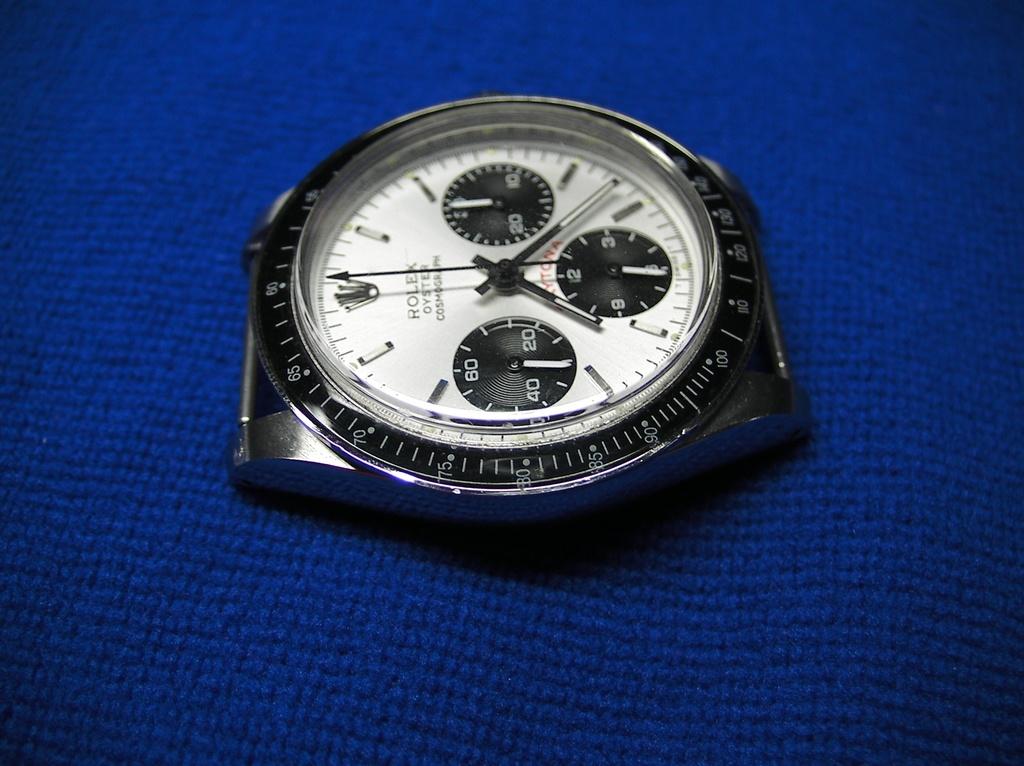What time does the watch read?
Give a very brief answer. 7:24. 